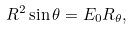<formula> <loc_0><loc_0><loc_500><loc_500>R ^ { 2 } \sin \theta = E _ { 0 } R _ { \theta } ,</formula> 